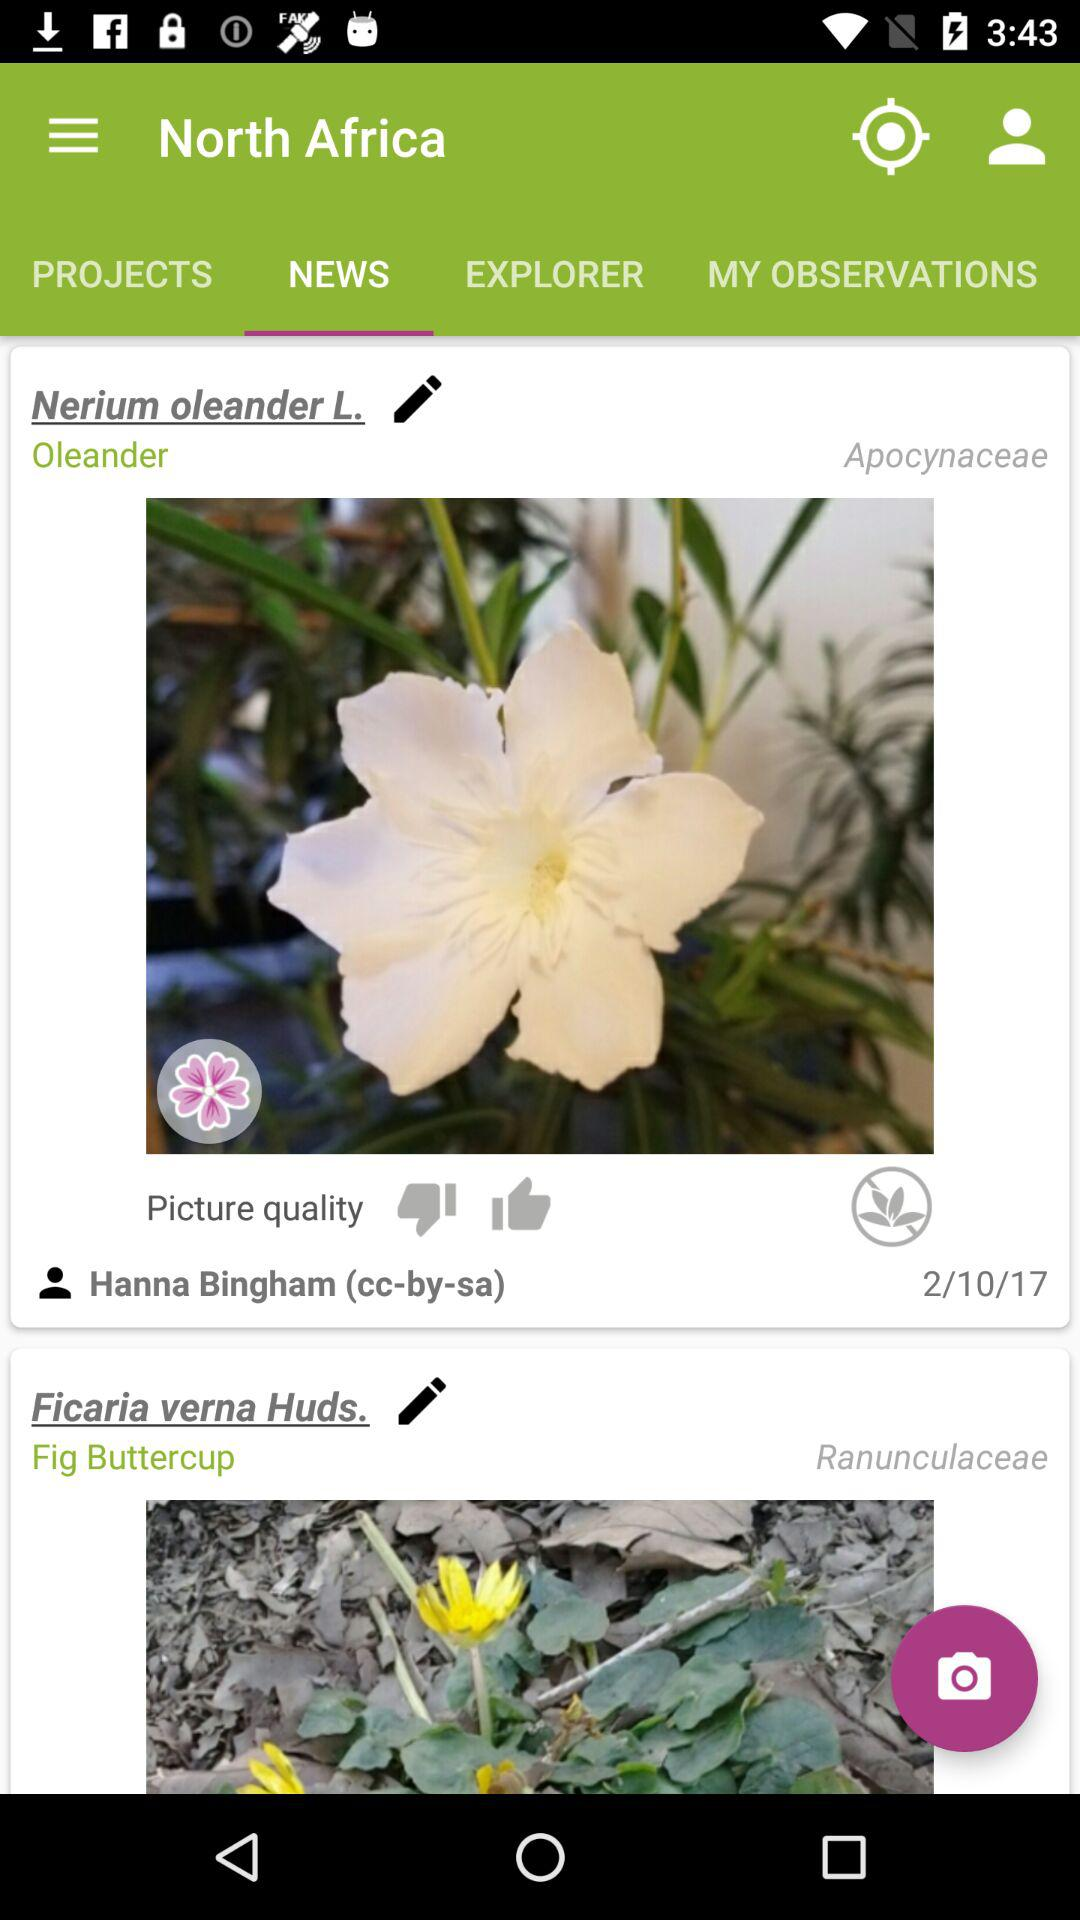Which tab is selected right now? Right now, the "NEWS" tab is selected. 